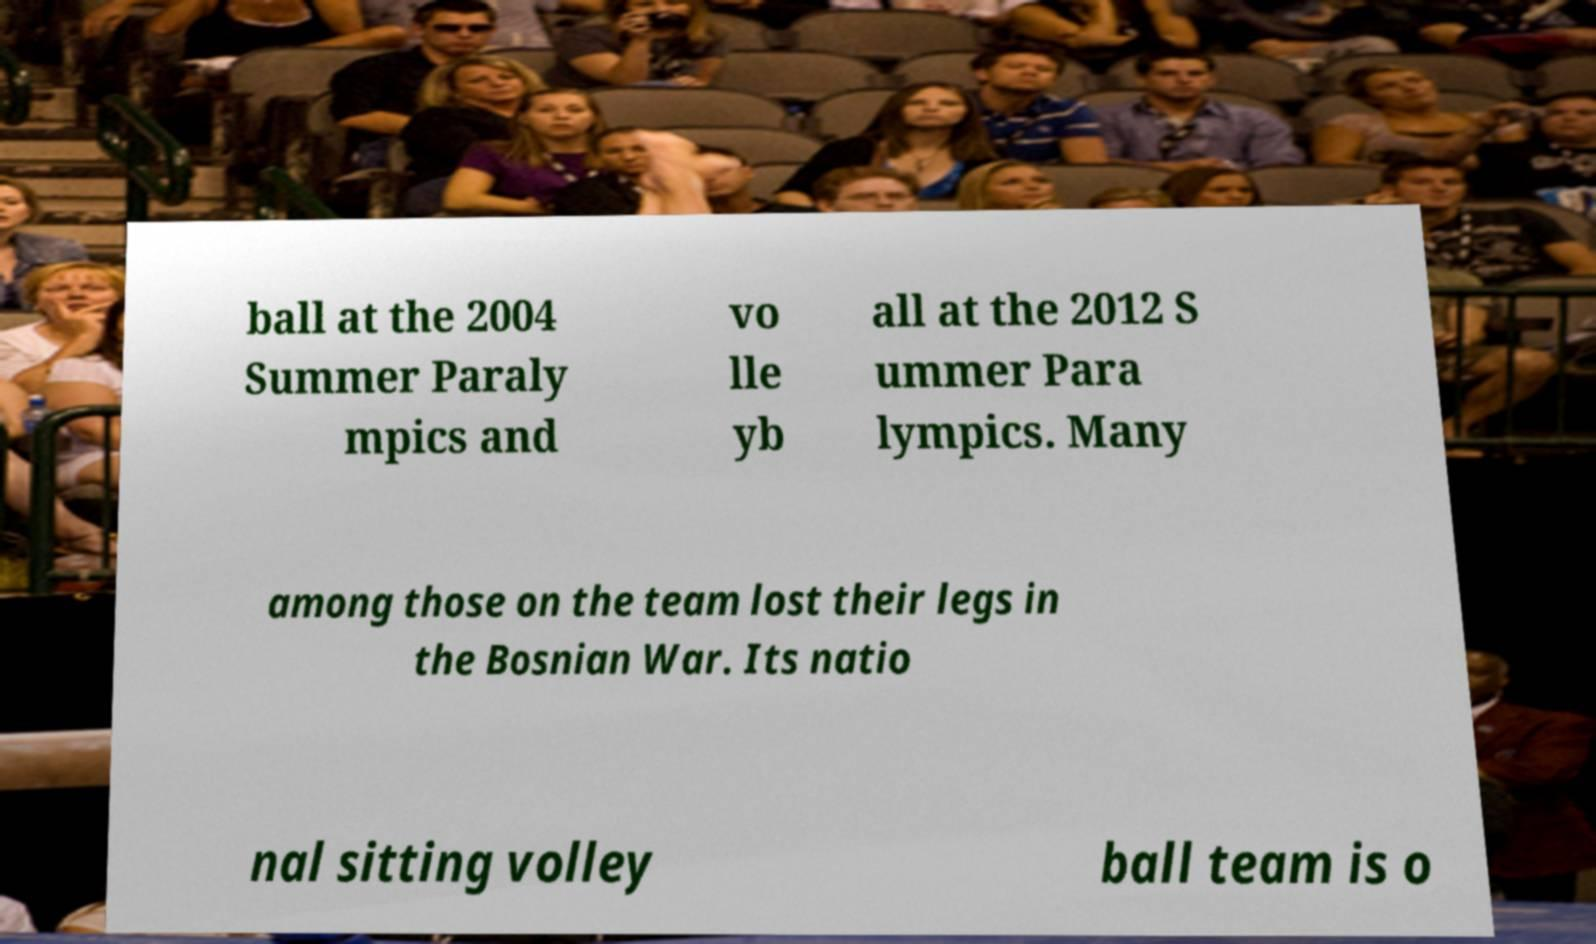Please read and relay the text visible in this image. What does it say? ball at the 2004 Summer Paraly mpics and vo lle yb all at the 2012 S ummer Para lympics. Many among those on the team lost their legs in the Bosnian War. Its natio nal sitting volley ball team is o 